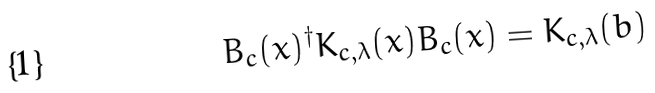Convert formula to latex. <formula><loc_0><loc_0><loc_500><loc_500>B _ { c } ( x ) ^ { \dagger } K _ { c , \lambda } ( x ) B _ { c } ( x ) = K _ { c , \lambda } ( b )</formula> 